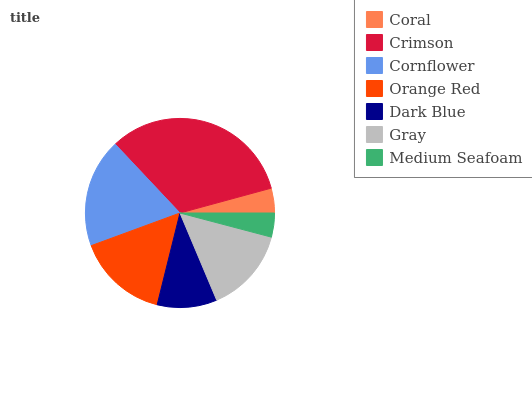Is Medium Seafoam the minimum?
Answer yes or no. Yes. Is Crimson the maximum?
Answer yes or no. Yes. Is Cornflower the minimum?
Answer yes or no. No. Is Cornflower the maximum?
Answer yes or no. No. Is Crimson greater than Cornflower?
Answer yes or no. Yes. Is Cornflower less than Crimson?
Answer yes or no. Yes. Is Cornflower greater than Crimson?
Answer yes or no. No. Is Crimson less than Cornflower?
Answer yes or no. No. Is Gray the high median?
Answer yes or no. Yes. Is Gray the low median?
Answer yes or no. Yes. Is Medium Seafoam the high median?
Answer yes or no. No. Is Crimson the low median?
Answer yes or no. No. 